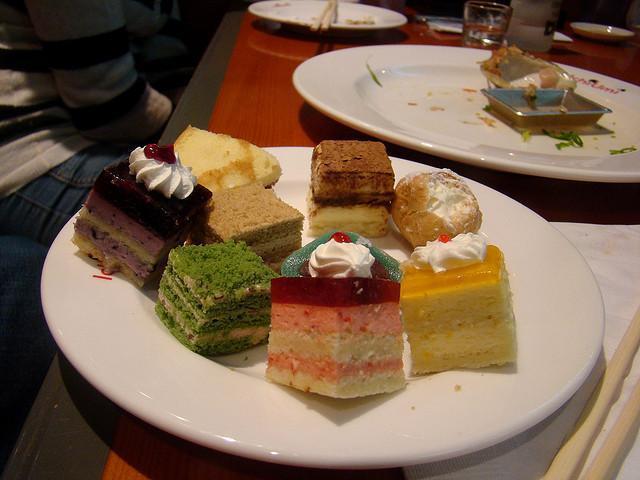What is the English translation of the French name for these?
Pick the right solution, then justify: 'Answer: answer
Rationale: rationale.'
Options: Little cakes, little oven, small squares, mini bites. Answer: little oven.
Rationale: They are mini. 